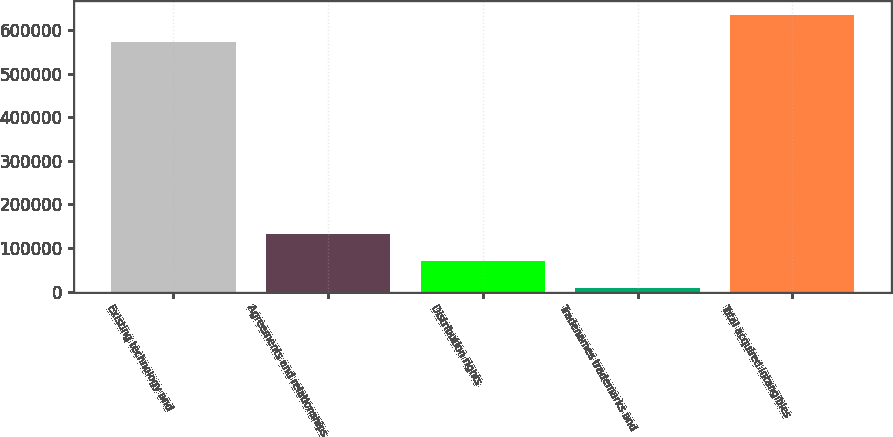<chart> <loc_0><loc_0><loc_500><loc_500><bar_chart><fcel>Existing technology and<fcel>Agreements and relationships<fcel>Distribution rights<fcel>Tradenames trademarks and<fcel>Total acquired intangibles<nl><fcel>572315<fcel>133283<fcel>70820.3<fcel>8358<fcel>634777<nl></chart> 